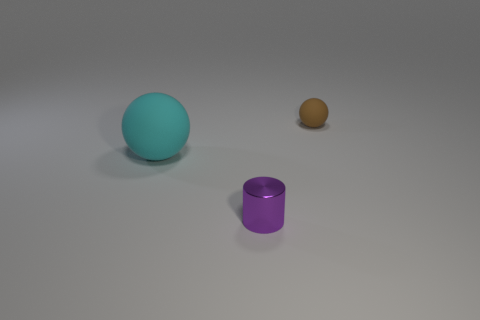Do the thing that is right of the tiny purple cylinder and the sphere that is in front of the small matte thing have the same material?
Provide a succinct answer. Yes. How many other brown things have the same material as the large thing?
Make the answer very short. 1. The cylinder is what color?
Make the answer very short. Purple. Do the tiny thing that is to the left of the small brown rubber ball and the small thing that is behind the big rubber object have the same shape?
Your answer should be very brief. No. There is a matte object to the left of the purple shiny cylinder; what color is it?
Your answer should be compact. Cyan. Are there fewer small brown rubber things left of the small purple metallic cylinder than metallic cylinders that are behind the large cyan rubber object?
Ensure brevity in your answer.  No. What number of other things are there of the same material as the small purple thing
Your answer should be very brief. 0. Is the material of the cyan sphere the same as the purple cylinder?
Your response must be concise. No. What number of other things are there of the same size as the brown sphere?
Your response must be concise. 1. There is a rubber sphere that is left of the tiny thing that is in front of the brown matte ball; what is its size?
Your answer should be compact. Large. 